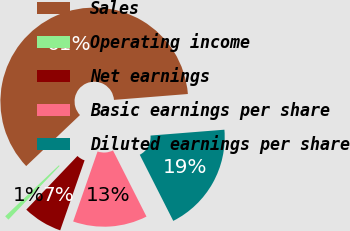<chart> <loc_0><loc_0><loc_500><loc_500><pie_chart><fcel>Sales<fcel>Operating income<fcel>Net earnings<fcel>Basic earnings per share<fcel>Diluted earnings per share<nl><fcel>60.82%<fcel>0.79%<fcel>6.79%<fcel>12.8%<fcel>18.8%<nl></chart> 